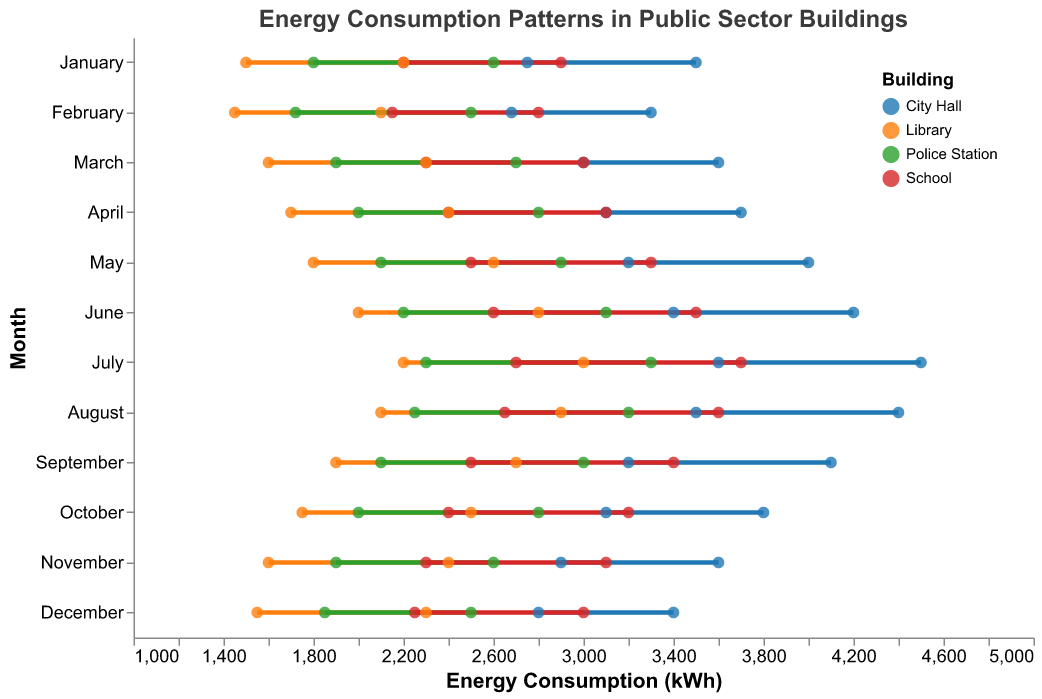What is the title of the plot? The title of the plot is usually located at the top center of the figure, and it provides a summary of what the plot is about. In this case, it says "Energy Consumption Patterns in Public Sector Buildings".
Answer: Energy Consumption Patterns in Public Sector Buildings What months show both minimum and maximum energy consumption for City Hall exceeding 4000 kWh? By examining the plot, City Hall exceeds 4000 kWh in both the minimum and maximum ranges only in July and August. They are marked with taller lines going beyond 4000 kWh.
Answer: July, August Which building has the highest maximum energy consumption in July? To find the highest maximum energy consumption in July, look at the building with the tallest point in July. The tallest point belongs to City Hall with 4500 kWh.
Answer: City Hall Does the Library's minimum energy consumption ever surpass any other building's maximum energy consumption? By scanning through the plot, Library's minimum values range from 1450 to 2200 kWh, which never surpasses the maximum energy consumption of any other building, as even the lowest maximum is 2500 kWh observed in other buildings.
Answer: No What's the average range of energy consumption for the School in June? For June, the School's energy consumption ranges from 2600 to 3500 kWh. Calculating the average range involves summing the minimum and maximum values and dividing by 2: (2600 + 3500) / 2 = 3050 kWh.
Answer: 3050 kWh In which month does the Police Station have the narrowest range of energy consumption? To find the narrowest range, look where the difference between max and min energy consumption for the Police Station is smallest. The range for each month is: Jan 800, Feb 780, Mar 800, Apr 800, May 800, Jun 900, Jul 1000, Aug 950, Sep 900, Oct 800, Nov 700, Dec 650. December has the range of 650 kWh, the narrowest.
Answer: December How does the energy consumption pattern for the Library in May compare with that of the School in May? Comparing the max and min energy consumption for both in May: Library ranges 1800 to 2600 kWh; School ranges 2500 to 3300 kWh. School has both higher minimum and maximum consumption compared to the Library.
Answer: School has higher energy consumption Which building and month have the largest range in energy consumption values? Looking for the longest line (largest gap between min and max), City Hall in July has the largest range, from 3600 to 4500 kWh, a range of 900 kWh.
Answer: City Hall in July During which month does City Hall have its minimum energy consumption, and what is the value? From the plot, City Hall's minimum energy consumption is in February with 2680 kWh.
Answer: February, 2680 kWh 